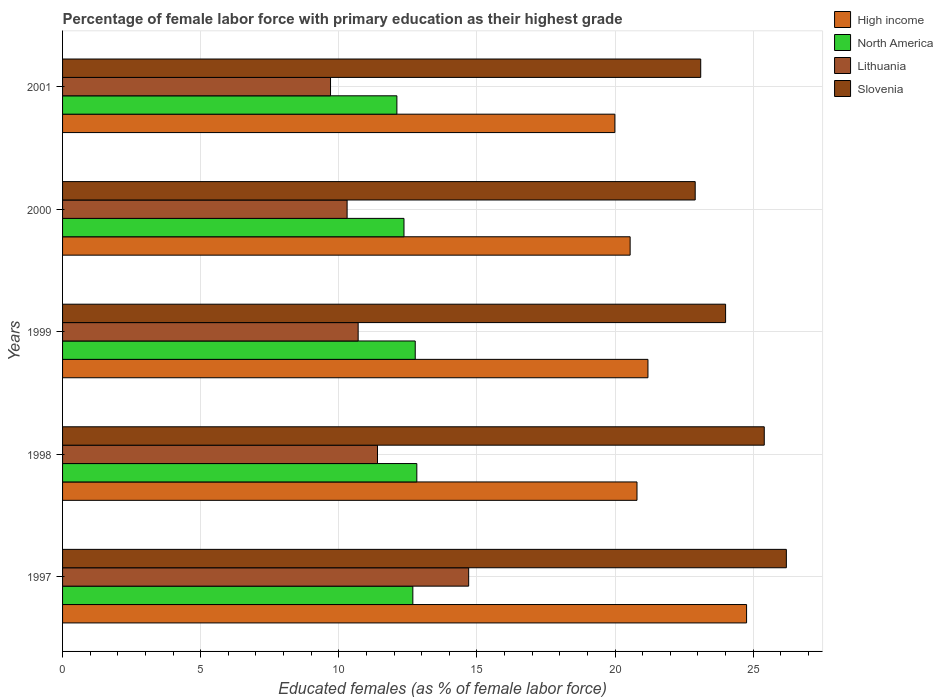How many bars are there on the 1st tick from the bottom?
Give a very brief answer. 4. In how many cases, is the number of bars for a given year not equal to the number of legend labels?
Provide a succinct answer. 0. What is the percentage of female labor force with primary education in Lithuania in 1998?
Give a very brief answer. 11.4. Across all years, what is the maximum percentage of female labor force with primary education in Slovenia?
Your answer should be compact. 26.2. Across all years, what is the minimum percentage of female labor force with primary education in High income?
Offer a very short reply. 19.99. What is the total percentage of female labor force with primary education in Lithuania in the graph?
Ensure brevity in your answer.  56.8. What is the difference between the percentage of female labor force with primary education in High income in 1997 and that in 2001?
Offer a terse response. 4.77. What is the difference between the percentage of female labor force with primary education in North America in 1997 and the percentage of female labor force with primary education in Lithuania in 1999?
Keep it short and to the point. 1.98. What is the average percentage of female labor force with primary education in North America per year?
Offer a terse response. 12.55. In the year 2000, what is the difference between the percentage of female labor force with primary education in North America and percentage of female labor force with primary education in Lithuania?
Your answer should be very brief. 2.06. In how many years, is the percentage of female labor force with primary education in Slovenia greater than 22 %?
Your response must be concise. 5. What is the ratio of the percentage of female labor force with primary education in North America in 1998 to that in 2001?
Keep it short and to the point. 1.06. Is the percentage of female labor force with primary education in Slovenia in 1997 less than that in 2000?
Give a very brief answer. No. What is the difference between the highest and the second highest percentage of female labor force with primary education in Slovenia?
Offer a terse response. 0.8. What is the difference between the highest and the lowest percentage of female labor force with primary education in High income?
Your response must be concise. 4.77. Is the sum of the percentage of female labor force with primary education in High income in 1998 and 2001 greater than the maximum percentage of female labor force with primary education in Slovenia across all years?
Offer a terse response. Yes. What does the 1st bar from the top in 2001 represents?
Your answer should be very brief. Slovenia. Are all the bars in the graph horizontal?
Your answer should be very brief. Yes. How many years are there in the graph?
Keep it short and to the point. 5. What is the difference between two consecutive major ticks on the X-axis?
Offer a very short reply. 5. Are the values on the major ticks of X-axis written in scientific E-notation?
Give a very brief answer. No. Does the graph contain grids?
Offer a very short reply. Yes. How many legend labels are there?
Provide a short and direct response. 4. What is the title of the graph?
Your response must be concise. Percentage of female labor force with primary education as their highest grade. Does "Bolivia" appear as one of the legend labels in the graph?
Offer a terse response. No. What is the label or title of the X-axis?
Give a very brief answer. Educated females (as % of female labor force). What is the label or title of the Y-axis?
Keep it short and to the point. Years. What is the Educated females (as % of female labor force) in High income in 1997?
Keep it short and to the point. 24.76. What is the Educated females (as % of female labor force) in North America in 1997?
Make the answer very short. 12.68. What is the Educated females (as % of female labor force) of Lithuania in 1997?
Provide a short and direct response. 14.7. What is the Educated females (as % of female labor force) in Slovenia in 1997?
Give a very brief answer. 26.2. What is the Educated females (as % of female labor force) in High income in 1998?
Your answer should be very brief. 20.79. What is the Educated females (as % of female labor force) in North America in 1998?
Your answer should be very brief. 12.82. What is the Educated females (as % of female labor force) in Lithuania in 1998?
Provide a succinct answer. 11.4. What is the Educated females (as % of female labor force) of Slovenia in 1998?
Give a very brief answer. 25.4. What is the Educated females (as % of female labor force) of High income in 1999?
Your response must be concise. 21.19. What is the Educated females (as % of female labor force) in North America in 1999?
Make the answer very short. 12.77. What is the Educated females (as % of female labor force) in Lithuania in 1999?
Provide a succinct answer. 10.7. What is the Educated females (as % of female labor force) in High income in 2000?
Ensure brevity in your answer.  20.54. What is the Educated females (as % of female labor force) in North America in 2000?
Your response must be concise. 12.36. What is the Educated females (as % of female labor force) in Lithuania in 2000?
Provide a succinct answer. 10.3. What is the Educated females (as % of female labor force) in Slovenia in 2000?
Give a very brief answer. 22.9. What is the Educated females (as % of female labor force) in High income in 2001?
Your answer should be very brief. 19.99. What is the Educated females (as % of female labor force) in North America in 2001?
Keep it short and to the point. 12.1. What is the Educated females (as % of female labor force) of Lithuania in 2001?
Offer a terse response. 9.7. What is the Educated females (as % of female labor force) in Slovenia in 2001?
Ensure brevity in your answer.  23.1. Across all years, what is the maximum Educated females (as % of female labor force) of High income?
Your response must be concise. 24.76. Across all years, what is the maximum Educated females (as % of female labor force) in North America?
Offer a terse response. 12.82. Across all years, what is the maximum Educated females (as % of female labor force) of Lithuania?
Provide a succinct answer. 14.7. Across all years, what is the maximum Educated females (as % of female labor force) in Slovenia?
Provide a succinct answer. 26.2. Across all years, what is the minimum Educated females (as % of female labor force) of High income?
Provide a short and direct response. 19.99. Across all years, what is the minimum Educated females (as % of female labor force) in North America?
Your answer should be compact. 12.1. Across all years, what is the minimum Educated females (as % of female labor force) of Lithuania?
Offer a terse response. 9.7. Across all years, what is the minimum Educated females (as % of female labor force) of Slovenia?
Your response must be concise. 22.9. What is the total Educated females (as % of female labor force) in High income in the graph?
Ensure brevity in your answer.  107.28. What is the total Educated females (as % of female labor force) of North America in the graph?
Give a very brief answer. 62.73. What is the total Educated females (as % of female labor force) of Lithuania in the graph?
Provide a short and direct response. 56.8. What is the total Educated females (as % of female labor force) in Slovenia in the graph?
Ensure brevity in your answer.  121.6. What is the difference between the Educated females (as % of female labor force) in High income in 1997 and that in 1998?
Provide a short and direct response. 3.97. What is the difference between the Educated females (as % of female labor force) in North America in 1997 and that in 1998?
Offer a terse response. -0.14. What is the difference between the Educated females (as % of female labor force) in Lithuania in 1997 and that in 1998?
Ensure brevity in your answer.  3.3. What is the difference between the Educated females (as % of female labor force) of High income in 1997 and that in 1999?
Provide a short and direct response. 3.57. What is the difference between the Educated females (as % of female labor force) of North America in 1997 and that in 1999?
Offer a terse response. -0.09. What is the difference between the Educated females (as % of female labor force) in High income in 1997 and that in 2000?
Keep it short and to the point. 4.21. What is the difference between the Educated females (as % of female labor force) of North America in 1997 and that in 2000?
Ensure brevity in your answer.  0.32. What is the difference between the Educated females (as % of female labor force) in Lithuania in 1997 and that in 2000?
Offer a very short reply. 4.4. What is the difference between the Educated females (as % of female labor force) in Slovenia in 1997 and that in 2000?
Provide a succinct answer. 3.3. What is the difference between the Educated females (as % of female labor force) of High income in 1997 and that in 2001?
Provide a succinct answer. 4.77. What is the difference between the Educated females (as % of female labor force) of North America in 1997 and that in 2001?
Make the answer very short. 0.58. What is the difference between the Educated females (as % of female labor force) in High income in 1998 and that in 1999?
Offer a terse response. -0.4. What is the difference between the Educated females (as % of female labor force) of North America in 1998 and that in 1999?
Ensure brevity in your answer.  0.06. What is the difference between the Educated females (as % of female labor force) of Slovenia in 1998 and that in 1999?
Your response must be concise. 1.4. What is the difference between the Educated females (as % of female labor force) in High income in 1998 and that in 2000?
Your answer should be compact. 0.25. What is the difference between the Educated females (as % of female labor force) of North America in 1998 and that in 2000?
Make the answer very short. 0.46. What is the difference between the Educated females (as % of female labor force) in Lithuania in 1998 and that in 2000?
Provide a succinct answer. 1.1. What is the difference between the Educated females (as % of female labor force) of Slovenia in 1998 and that in 2000?
Give a very brief answer. 2.5. What is the difference between the Educated females (as % of female labor force) of High income in 1998 and that in 2001?
Your answer should be compact. 0.8. What is the difference between the Educated females (as % of female labor force) in North America in 1998 and that in 2001?
Provide a succinct answer. 0.72. What is the difference between the Educated females (as % of female labor force) in Lithuania in 1998 and that in 2001?
Give a very brief answer. 1.7. What is the difference between the Educated females (as % of female labor force) in High income in 1999 and that in 2000?
Make the answer very short. 0.64. What is the difference between the Educated females (as % of female labor force) in North America in 1999 and that in 2000?
Give a very brief answer. 0.41. What is the difference between the Educated females (as % of female labor force) of Lithuania in 1999 and that in 2000?
Give a very brief answer. 0.4. What is the difference between the Educated females (as % of female labor force) in High income in 1999 and that in 2001?
Ensure brevity in your answer.  1.2. What is the difference between the Educated females (as % of female labor force) in North America in 1999 and that in 2001?
Your answer should be very brief. 0.66. What is the difference between the Educated females (as % of female labor force) of Slovenia in 1999 and that in 2001?
Your response must be concise. 0.9. What is the difference between the Educated females (as % of female labor force) of High income in 2000 and that in 2001?
Provide a short and direct response. 0.55. What is the difference between the Educated females (as % of female labor force) of North America in 2000 and that in 2001?
Offer a very short reply. 0.26. What is the difference between the Educated females (as % of female labor force) of Lithuania in 2000 and that in 2001?
Your response must be concise. 0.6. What is the difference between the Educated females (as % of female labor force) of High income in 1997 and the Educated females (as % of female labor force) of North America in 1998?
Keep it short and to the point. 11.94. What is the difference between the Educated females (as % of female labor force) in High income in 1997 and the Educated females (as % of female labor force) in Lithuania in 1998?
Give a very brief answer. 13.36. What is the difference between the Educated females (as % of female labor force) of High income in 1997 and the Educated females (as % of female labor force) of Slovenia in 1998?
Provide a short and direct response. -0.64. What is the difference between the Educated females (as % of female labor force) of North America in 1997 and the Educated females (as % of female labor force) of Lithuania in 1998?
Your response must be concise. 1.28. What is the difference between the Educated females (as % of female labor force) in North America in 1997 and the Educated females (as % of female labor force) in Slovenia in 1998?
Your answer should be compact. -12.72. What is the difference between the Educated females (as % of female labor force) in High income in 1997 and the Educated females (as % of female labor force) in North America in 1999?
Keep it short and to the point. 11.99. What is the difference between the Educated females (as % of female labor force) of High income in 1997 and the Educated females (as % of female labor force) of Lithuania in 1999?
Provide a succinct answer. 14.06. What is the difference between the Educated females (as % of female labor force) of High income in 1997 and the Educated females (as % of female labor force) of Slovenia in 1999?
Your response must be concise. 0.76. What is the difference between the Educated females (as % of female labor force) of North America in 1997 and the Educated females (as % of female labor force) of Lithuania in 1999?
Your response must be concise. 1.98. What is the difference between the Educated females (as % of female labor force) in North America in 1997 and the Educated females (as % of female labor force) in Slovenia in 1999?
Provide a succinct answer. -11.32. What is the difference between the Educated females (as % of female labor force) of High income in 1997 and the Educated females (as % of female labor force) of North America in 2000?
Offer a very short reply. 12.4. What is the difference between the Educated females (as % of female labor force) of High income in 1997 and the Educated females (as % of female labor force) of Lithuania in 2000?
Offer a terse response. 14.46. What is the difference between the Educated females (as % of female labor force) in High income in 1997 and the Educated females (as % of female labor force) in Slovenia in 2000?
Your response must be concise. 1.86. What is the difference between the Educated females (as % of female labor force) in North America in 1997 and the Educated females (as % of female labor force) in Lithuania in 2000?
Your answer should be compact. 2.38. What is the difference between the Educated females (as % of female labor force) in North America in 1997 and the Educated females (as % of female labor force) in Slovenia in 2000?
Your answer should be compact. -10.22. What is the difference between the Educated females (as % of female labor force) of Lithuania in 1997 and the Educated females (as % of female labor force) of Slovenia in 2000?
Your response must be concise. -8.2. What is the difference between the Educated females (as % of female labor force) in High income in 1997 and the Educated females (as % of female labor force) in North America in 2001?
Your answer should be very brief. 12.66. What is the difference between the Educated females (as % of female labor force) of High income in 1997 and the Educated females (as % of female labor force) of Lithuania in 2001?
Offer a very short reply. 15.06. What is the difference between the Educated females (as % of female labor force) of High income in 1997 and the Educated females (as % of female labor force) of Slovenia in 2001?
Provide a short and direct response. 1.66. What is the difference between the Educated females (as % of female labor force) in North America in 1997 and the Educated females (as % of female labor force) in Lithuania in 2001?
Provide a succinct answer. 2.98. What is the difference between the Educated females (as % of female labor force) of North America in 1997 and the Educated females (as % of female labor force) of Slovenia in 2001?
Ensure brevity in your answer.  -10.42. What is the difference between the Educated females (as % of female labor force) in High income in 1998 and the Educated females (as % of female labor force) in North America in 1999?
Give a very brief answer. 8.03. What is the difference between the Educated females (as % of female labor force) of High income in 1998 and the Educated females (as % of female labor force) of Lithuania in 1999?
Make the answer very short. 10.09. What is the difference between the Educated females (as % of female labor force) in High income in 1998 and the Educated females (as % of female labor force) in Slovenia in 1999?
Make the answer very short. -3.21. What is the difference between the Educated females (as % of female labor force) of North America in 1998 and the Educated females (as % of female labor force) of Lithuania in 1999?
Your answer should be very brief. 2.12. What is the difference between the Educated females (as % of female labor force) in North America in 1998 and the Educated females (as % of female labor force) in Slovenia in 1999?
Keep it short and to the point. -11.18. What is the difference between the Educated females (as % of female labor force) of High income in 1998 and the Educated females (as % of female labor force) of North America in 2000?
Keep it short and to the point. 8.43. What is the difference between the Educated females (as % of female labor force) in High income in 1998 and the Educated females (as % of female labor force) in Lithuania in 2000?
Keep it short and to the point. 10.49. What is the difference between the Educated females (as % of female labor force) of High income in 1998 and the Educated females (as % of female labor force) of Slovenia in 2000?
Your response must be concise. -2.11. What is the difference between the Educated females (as % of female labor force) of North America in 1998 and the Educated females (as % of female labor force) of Lithuania in 2000?
Offer a very short reply. 2.52. What is the difference between the Educated females (as % of female labor force) of North America in 1998 and the Educated females (as % of female labor force) of Slovenia in 2000?
Provide a short and direct response. -10.08. What is the difference between the Educated females (as % of female labor force) of High income in 1998 and the Educated females (as % of female labor force) of North America in 2001?
Your answer should be very brief. 8.69. What is the difference between the Educated females (as % of female labor force) of High income in 1998 and the Educated females (as % of female labor force) of Lithuania in 2001?
Provide a short and direct response. 11.09. What is the difference between the Educated females (as % of female labor force) in High income in 1998 and the Educated females (as % of female labor force) in Slovenia in 2001?
Make the answer very short. -2.31. What is the difference between the Educated females (as % of female labor force) of North America in 1998 and the Educated females (as % of female labor force) of Lithuania in 2001?
Your response must be concise. 3.12. What is the difference between the Educated females (as % of female labor force) in North America in 1998 and the Educated females (as % of female labor force) in Slovenia in 2001?
Your answer should be compact. -10.28. What is the difference between the Educated females (as % of female labor force) in High income in 1999 and the Educated females (as % of female labor force) in North America in 2000?
Make the answer very short. 8.83. What is the difference between the Educated females (as % of female labor force) in High income in 1999 and the Educated females (as % of female labor force) in Lithuania in 2000?
Your response must be concise. 10.89. What is the difference between the Educated females (as % of female labor force) in High income in 1999 and the Educated females (as % of female labor force) in Slovenia in 2000?
Offer a terse response. -1.71. What is the difference between the Educated females (as % of female labor force) of North America in 1999 and the Educated females (as % of female labor force) of Lithuania in 2000?
Your response must be concise. 2.47. What is the difference between the Educated females (as % of female labor force) of North America in 1999 and the Educated females (as % of female labor force) of Slovenia in 2000?
Your response must be concise. -10.13. What is the difference between the Educated females (as % of female labor force) of Lithuania in 1999 and the Educated females (as % of female labor force) of Slovenia in 2000?
Make the answer very short. -12.2. What is the difference between the Educated females (as % of female labor force) of High income in 1999 and the Educated females (as % of female labor force) of North America in 2001?
Give a very brief answer. 9.09. What is the difference between the Educated females (as % of female labor force) of High income in 1999 and the Educated females (as % of female labor force) of Lithuania in 2001?
Provide a succinct answer. 11.49. What is the difference between the Educated females (as % of female labor force) of High income in 1999 and the Educated females (as % of female labor force) of Slovenia in 2001?
Provide a short and direct response. -1.91. What is the difference between the Educated females (as % of female labor force) in North America in 1999 and the Educated females (as % of female labor force) in Lithuania in 2001?
Ensure brevity in your answer.  3.07. What is the difference between the Educated females (as % of female labor force) of North America in 1999 and the Educated females (as % of female labor force) of Slovenia in 2001?
Your response must be concise. -10.33. What is the difference between the Educated females (as % of female labor force) of Lithuania in 1999 and the Educated females (as % of female labor force) of Slovenia in 2001?
Your response must be concise. -12.4. What is the difference between the Educated females (as % of female labor force) of High income in 2000 and the Educated females (as % of female labor force) of North America in 2001?
Make the answer very short. 8.44. What is the difference between the Educated females (as % of female labor force) in High income in 2000 and the Educated females (as % of female labor force) in Lithuania in 2001?
Give a very brief answer. 10.84. What is the difference between the Educated females (as % of female labor force) of High income in 2000 and the Educated females (as % of female labor force) of Slovenia in 2001?
Give a very brief answer. -2.56. What is the difference between the Educated females (as % of female labor force) of North America in 2000 and the Educated females (as % of female labor force) of Lithuania in 2001?
Offer a very short reply. 2.66. What is the difference between the Educated females (as % of female labor force) of North America in 2000 and the Educated females (as % of female labor force) of Slovenia in 2001?
Keep it short and to the point. -10.74. What is the difference between the Educated females (as % of female labor force) of Lithuania in 2000 and the Educated females (as % of female labor force) of Slovenia in 2001?
Provide a short and direct response. -12.8. What is the average Educated females (as % of female labor force) of High income per year?
Keep it short and to the point. 21.46. What is the average Educated females (as % of female labor force) of North America per year?
Your answer should be very brief. 12.55. What is the average Educated females (as % of female labor force) in Lithuania per year?
Provide a short and direct response. 11.36. What is the average Educated females (as % of female labor force) in Slovenia per year?
Make the answer very short. 24.32. In the year 1997, what is the difference between the Educated females (as % of female labor force) of High income and Educated females (as % of female labor force) of North America?
Offer a very short reply. 12.08. In the year 1997, what is the difference between the Educated females (as % of female labor force) of High income and Educated females (as % of female labor force) of Lithuania?
Provide a short and direct response. 10.06. In the year 1997, what is the difference between the Educated females (as % of female labor force) of High income and Educated females (as % of female labor force) of Slovenia?
Your answer should be compact. -1.44. In the year 1997, what is the difference between the Educated females (as % of female labor force) of North America and Educated females (as % of female labor force) of Lithuania?
Offer a terse response. -2.02. In the year 1997, what is the difference between the Educated females (as % of female labor force) in North America and Educated females (as % of female labor force) in Slovenia?
Your answer should be compact. -13.52. In the year 1997, what is the difference between the Educated females (as % of female labor force) of Lithuania and Educated females (as % of female labor force) of Slovenia?
Your response must be concise. -11.5. In the year 1998, what is the difference between the Educated females (as % of female labor force) of High income and Educated females (as % of female labor force) of North America?
Ensure brevity in your answer.  7.97. In the year 1998, what is the difference between the Educated females (as % of female labor force) of High income and Educated females (as % of female labor force) of Lithuania?
Offer a terse response. 9.39. In the year 1998, what is the difference between the Educated females (as % of female labor force) in High income and Educated females (as % of female labor force) in Slovenia?
Provide a short and direct response. -4.61. In the year 1998, what is the difference between the Educated females (as % of female labor force) in North America and Educated females (as % of female labor force) in Lithuania?
Your response must be concise. 1.42. In the year 1998, what is the difference between the Educated females (as % of female labor force) in North America and Educated females (as % of female labor force) in Slovenia?
Keep it short and to the point. -12.58. In the year 1998, what is the difference between the Educated females (as % of female labor force) in Lithuania and Educated females (as % of female labor force) in Slovenia?
Offer a terse response. -14. In the year 1999, what is the difference between the Educated females (as % of female labor force) in High income and Educated females (as % of female labor force) in North America?
Ensure brevity in your answer.  8.42. In the year 1999, what is the difference between the Educated females (as % of female labor force) of High income and Educated females (as % of female labor force) of Lithuania?
Make the answer very short. 10.49. In the year 1999, what is the difference between the Educated females (as % of female labor force) of High income and Educated females (as % of female labor force) of Slovenia?
Your answer should be compact. -2.81. In the year 1999, what is the difference between the Educated females (as % of female labor force) in North America and Educated females (as % of female labor force) in Lithuania?
Offer a very short reply. 2.07. In the year 1999, what is the difference between the Educated females (as % of female labor force) in North America and Educated females (as % of female labor force) in Slovenia?
Provide a succinct answer. -11.23. In the year 1999, what is the difference between the Educated females (as % of female labor force) in Lithuania and Educated females (as % of female labor force) in Slovenia?
Offer a terse response. -13.3. In the year 2000, what is the difference between the Educated females (as % of female labor force) of High income and Educated females (as % of female labor force) of North America?
Your response must be concise. 8.19. In the year 2000, what is the difference between the Educated females (as % of female labor force) in High income and Educated females (as % of female labor force) in Lithuania?
Your answer should be compact. 10.24. In the year 2000, what is the difference between the Educated females (as % of female labor force) of High income and Educated females (as % of female labor force) of Slovenia?
Keep it short and to the point. -2.36. In the year 2000, what is the difference between the Educated females (as % of female labor force) of North America and Educated females (as % of female labor force) of Lithuania?
Keep it short and to the point. 2.06. In the year 2000, what is the difference between the Educated females (as % of female labor force) of North America and Educated females (as % of female labor force) of Slovenia?
Offer a very short reply. -10.54. In the year 2000, what is the difference between the Educated females (as % of female labor force) of Lithuania and Educated females (as % of female labor force) of Slovenia?
Provide a succinct answer. -12.6. In the year 2001, what is the difference between the Educated females (as % of female labor force) in High income and Educated females (as % of female labor force) in North America?
Ensure brevity in your answer.  7.89. In the year 2001, what is the difference between the Educated females (as % of female labor force) of High income and Educated females (as % of female labor force) of Lithuania?
Offer a terse response. 10.29. In the year 2001, what is the difference between the Educated females (as % of female labor force) of High income and Educated females (as % of female labor force) of Slovenia?
Your answer should be very brief. -3.11. In the year 2001, what is the difference between the Educated females (as % of female labor force) in North America and Educated females (as % of female labor force) in Lithuania?
Make the answer very short. 2.4. In the year 2001, what is the difference between the Educated females (as % of female labor force) of North America and Educated females (as % of female labor force) of Slovenia?
Provide a short and direct response. -11. What is the ratio of the Educated females (as % of female labor force) in High income in 1997 to that in 1998?
Give a very brief answer. 1.19. What is the ratio of the Educated females (as % of female labor force) in North America in 1997 to that in 1998?
Make the answer very short. 0.99. What is the ratio of the Educated females (as % of female labor force) in Lithuania in 1997 to that in 1998?
Make the answer very short. 1.29. What is the ratio of the Educated females (as % of female labor force) of Slovenia in 1997 to that in 1998?
Make the answer very short. 1.03. What is the ratio of the Educated females (as % of female labor force) in High income in 1997 to that in 1999?
Offer a terse response. 1.17. What is the ratio of the Educated females (as % of female labor force) of North America in 1997 to that in 1999?
Ensure brevity in your answer.  0.99. What is the ratio of the Educated females (as % of female labor force) of Lithuania in 1997 to that in 1999?
Give a very brief answer. 1.37. What is the ratio of the Educated females (as % of female labor force) in Slovenia in 1997 to that in 1999?
Make the answer very short. 1.09. What is the ratio of the Educated females (as % of female labor force) in High income in 1997 to that in 2000?
Give a very brief answer. 1.21. What is the ratio of the Educated females (as % of female labor force) of North America in 1997 to that in 2000?
Your response must be concise. 1.03. What is the ratio of the Educated females (as % of female labor force) of Lithuania in 1997 to that in 2000?
Provide a succinct answer. 1.43. What is the ratio of the Educated females (as % of female labor force) of Slovenia in 1997 to that in 2000?
Your answer should be compact. 1.14. What is the ratio of the Educated females (as % of female labor force) in High income in 1997 to that in 2001?
Your response must be concise. 1.24. What is the ratio of the Educated females (as % of female labor force) in North America in 1997 to that in 2001?
Your answer should be compact. 1.05. What is the ratio of the Educated females (as % of female labor force) of Lithuania in 1997 to that in 2001?
Your response must be concise. 1.52. What is the ratio of the Educated females (as % of female labor force) of Slovenia in 1997 to that in 2001?
Offer a very short reply. 1.13. What is the ratio of the Educated females (as % of female labor force) of High income in 1998 to that in 1999?
Your answer should be very brief. 0.98. What is the ratio of the Educated females (as % of female labor force) in Lithuania in 1998 to that in 1999?
Offer a very short reply. 1.07. What is the ratio of the Educated females (as % of female labor force) of Slovenia in 1998 to that in 1999?
Your answer should be compact. 1.06. What is the ratio of the Educated females (as % of female labor force) of High income in 1998 to that in 2000?
Offer a terse response. 1.01. What is the ratio of the Educated females (as % of female labor force) of North America in 1998 to that in 2000?
Make the answer very short. 1.04. What is the ratio of the Educated females (as % of female labor force) of Lithuania in 1998 to that in 2000?
Offer a terse response. 1.11. What is the ratio of the Educated females (as % of female labor force) of Slovenia in 1998 to that in 2000?
Your answer should be very brief. 1.11. What is the ratio of the Educated females (as % of female labor force) in High income in 1998 to that in 2001?
Provide a short and direct response. 1.04. What is the ratio of the Educated females (as % of female labor force) in North America in 1998 to that in 2001?
Give a very brief answer. 1.06. What is the ratio of the Educated females (as % of female labor force) of Lithuania in 1998 to that in 2001?
Your answer should be very brief. 1.18. What is the ratio of the Educated females (as % of female labor force) in Slovenia in 1998 to that in 2001?
Provide a succinct answer. 1.1. What is the ratio of the Educated females (as % of female labor force) of High income in 1999 to that in 2000?
Your answer should be very brief. 1.03. What is the ratio of the Educated females (as % of female labor force) of North America in 1999 to that in 2000?
Offer a terse response. 1.03. What is the ratio of the Educated females (as % of female labor force) in Lithuania in 1999 to that in 2000?
Your response must be concise. 1.04. What is the ratio of the Educated females (as % of female labor force) in Slovenia in 1999 to that in 2000?
Your response must be concise. 1.05. What is the ratio of the Educated females (as % of female labor force) in High income in 1999 to that in 2001?
Make the answer very short. 1.06. What is the ratio of the Educated females (as % of female labor force) in North America in 1999 to that in 2001?
Make the answer very short. 1.05. What is the ratio of the Educated females (as % of female labor force) of Lithuania in 1999 to that in 2001?
Offer a terse response. 1.1. What is the ratio of the Educated females (as % of female labor force) of Slovenia in 1999 to that in 2001?
Your answer should be compact. 1.04. What is the ratio of the Educated females (as % of female labor force) in High income in 2000 to that in 2001?
Ensure brevity in your answer.  1.03. What is the ratio of the Educated females (as % of female labor force) in North America in 2000 to that in 2001?
Ensure brevity in your answer.  1.02. What is the ratio of the Educated females (as % of female labor force) in Lithuania in 2000 to that in 2001?
Make the answer very short. 1.06. What is the ratio of the Educated females (as % of female labor force) in Slovenia in 2000 to that in 2001?
Provide a short and direct response. 0.99. What is the difference between the highest and the second highest Educated females (as % of female labor force) of High income?
Offer a terse response. 3.57. What is the difference between the highest and the second highest Educated females (as % of female labor force) of North America?
Your response must be concise. 0.06. What is the difference between the highest and the second highest Educated females (as % of female labor force) in Lithuania?
Make the answer very short. 3.3. What is the difference between the highest and the second highest Educated females (as % of female labor force) in Slovenia?
Your answer should be very brief. 0.8. What is the difference between the highest and the lowest Educated females (as % of female labor force) in High income?
Offer a terse response. 4.77. What is the difference between the highest and the lowest Educated females (as % of female labor force) of North America?
Offer a very short reply. 0.72. What is the difference between the highest and the lowest Educated females (as % of female labor force) in Slovenia?
Your answer should be very brief. 3.3. 